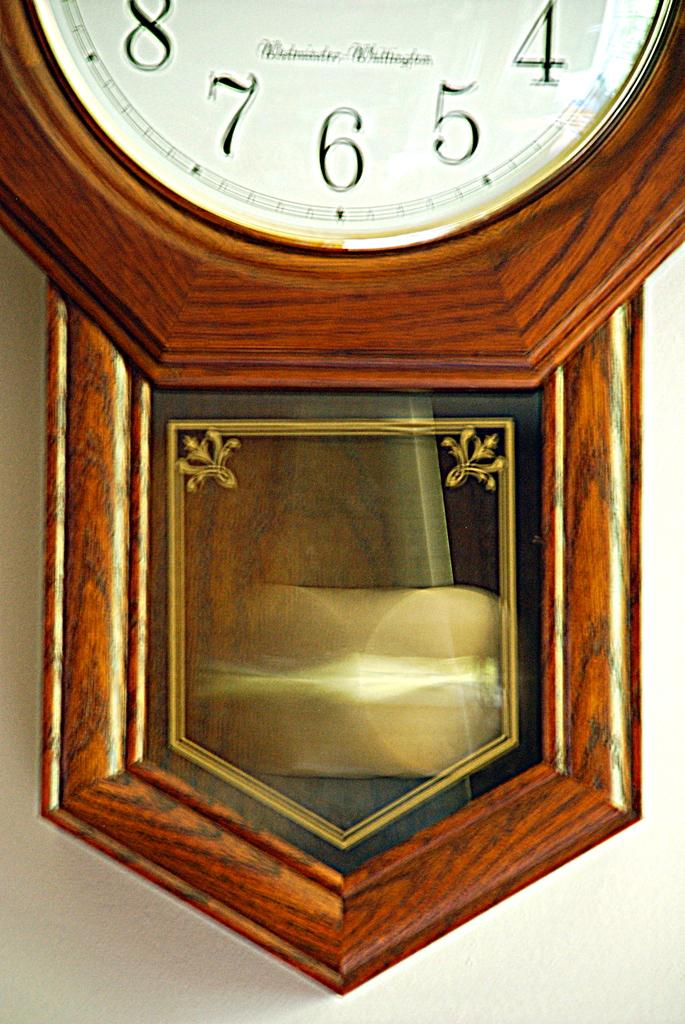What is the main object in the center of the image? There is a wall clock in the center of the image. What can be seen in the background of the image? There is a wall visible in the background of the image. Where is the kettle located in the image? There is no kettle present in the image. What direction is the wall clock pointing towards in the image? The image does not show the direction the wall clock is pointing, as it only shows the clock itself. 